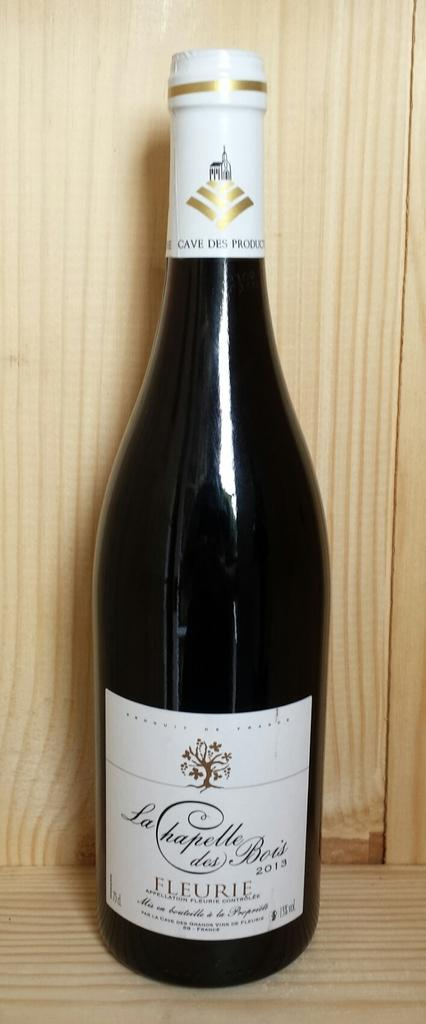<image>
Provide a brief description of the given image. A bottle of wine from 2013 sits in a wooden crate. 